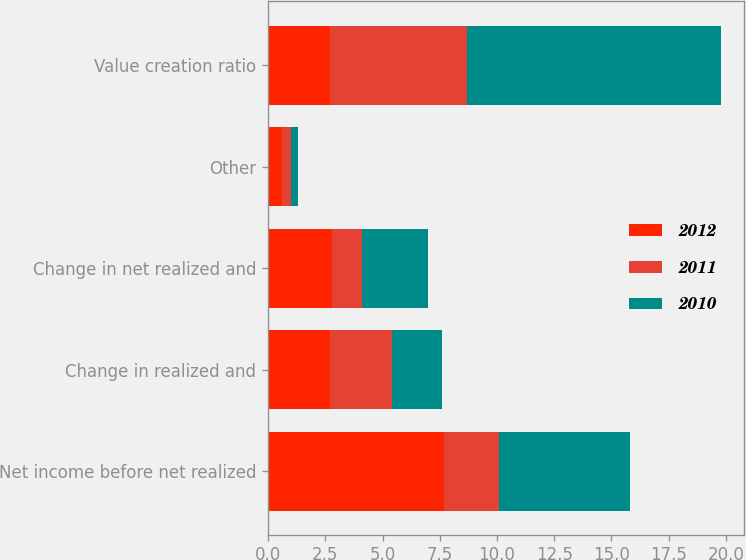Convert chart to OTSL. <chart><loc_0><loc_0><loc_500><loc_500><stacked_bar_chart><ecel><fcel>Net income before net realized<fcel>Change in realized and<fcel>Change in net realized and<fcel>Other<fcel>Value creation ratio<nl><fcel>2012<fcel>7.7<fcel>2.7<fcel>2.8<fcel>0.6<fcel>2.7<nl><fcel>2011<fcel>2.4<fcel>2.7<fcel>1.3<fcel>0.4<fcel>6<nl><fcel>2010<fcel>5.7<fcel>2.2<fcel>2.9<fcel>0.3<fcel>11.1<nl></chart> 